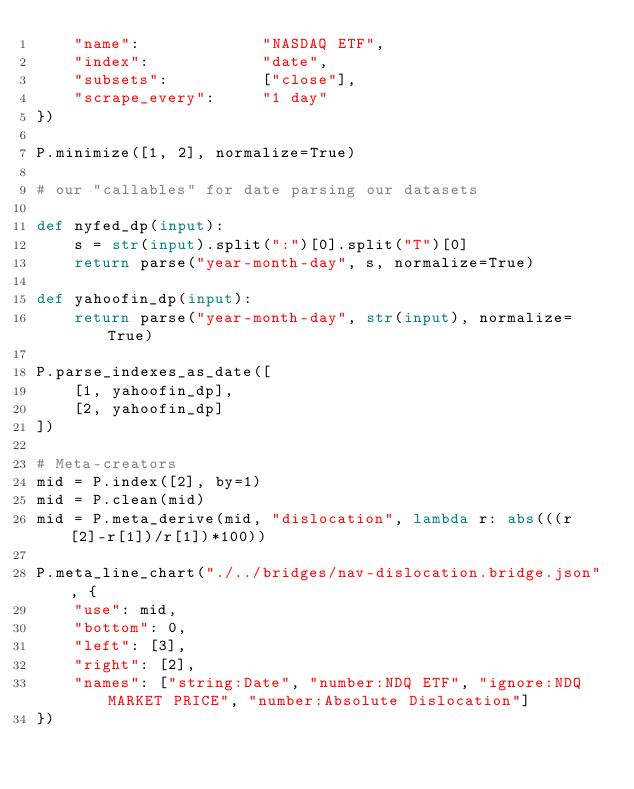Convert code to text. <code><loc_0><loc_0><loc_500><loc_500><_Python_>    "name":             "NASDAQ ETF",
    "index":            "date",
    "subsets":          ["close"],
    "scrape_every":     "1 day"
})

P.minimize([1, 2], normalize=True)

# our "callables" for date parsing our datasets

def nyfed_dp(input):
    s = str(input).split(":")[0].split("T")[0]
    return parse("year-month-day", s, normalize=True)

def yahoofin_dp(input):
    return parse("year-month-day", str(input), normalize=True)

P.parse_indexes_as_date([
    [1, yahoofin_dp],
    [2, yahoofin_dp]
])

# Meta-creators
mid = P.index([2], by=1)
mid = P.clean(mid)
mid = P.meta_derive(mid, "dislocation", lambda r: abs(((r[2]-r[1])/r[1])*100))

P.meta_line_chart("./../bridges/nav-dislocation.bridge.json", {
    "use": mid,
    "bottom": 0,
    "left": [3],
    "right": [2],
    "names": ["string:Date", "number:NDQ ETF", "ignore:NDQ MARKET PRICE", "number:Absolute Dislocation"]
})
</code> 